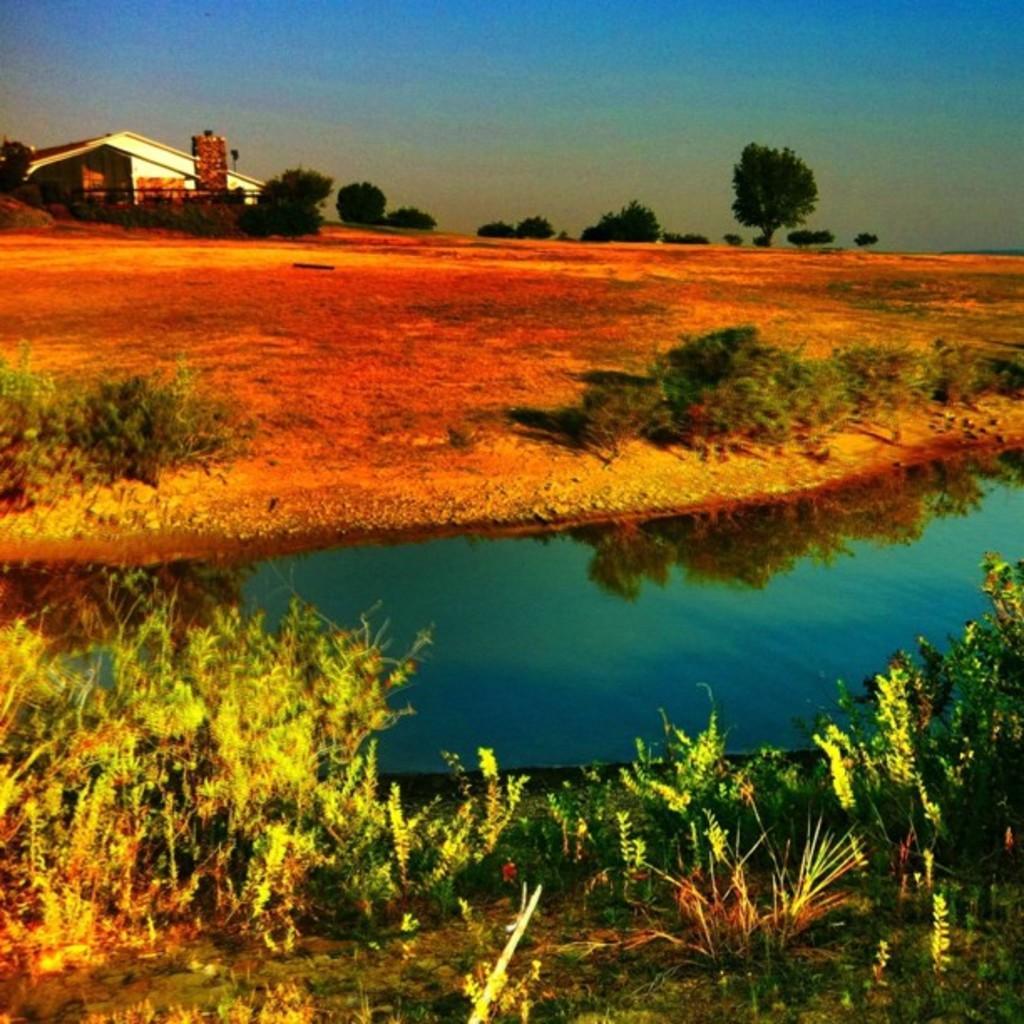Describe this image in one or two sentences. It looks like an edited image. We can see there are plants, water, a building, trees and the sky. 